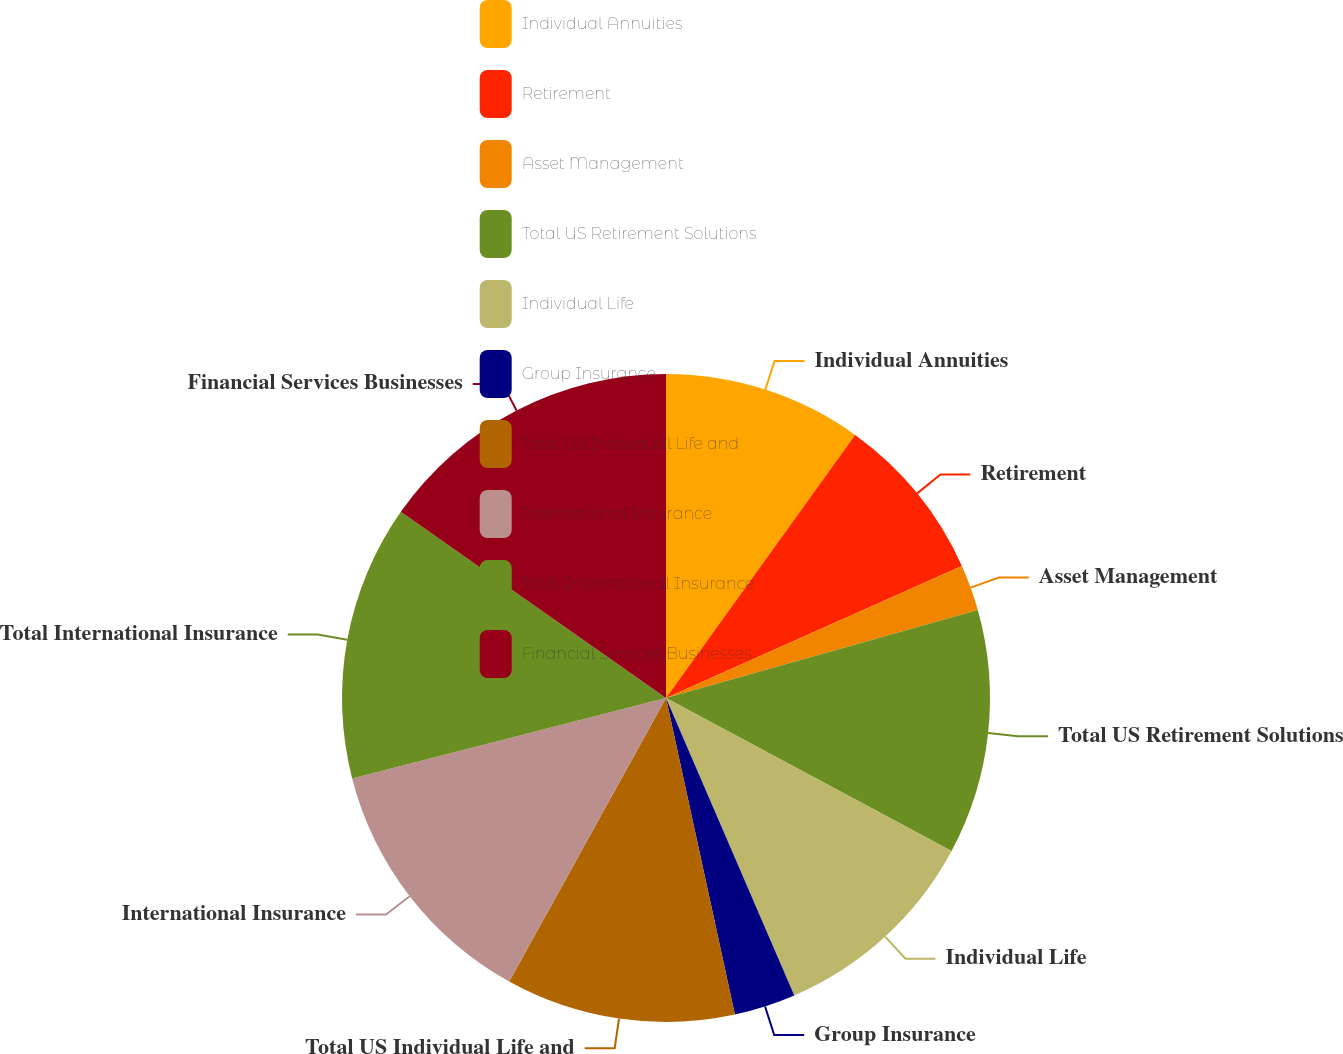Convert chart to OTSL. <chart><loc_0><loc_0><loc_500><loc_500><pie_chart><fcel>Individual Annuities<fcel>Retirement<fcel>Asset Management<fcel>Total US Retirement Solutions<fcel>Individual Life<fcel>Group Insurance<fcel>Total US Individual Life and<fcel>International Insurance<fcel>Total International Insurance<fcel>Financial Services Businesses<nl><fcel>9.92%<fcel>8.4%<fcel>2.3%<fcel>12.21%<fcel>10.69%<fcel>3.07%<fcel>11.45%<fcel>12.97%<fcel>13.73%<fcel>15.26%<nl></chart> 